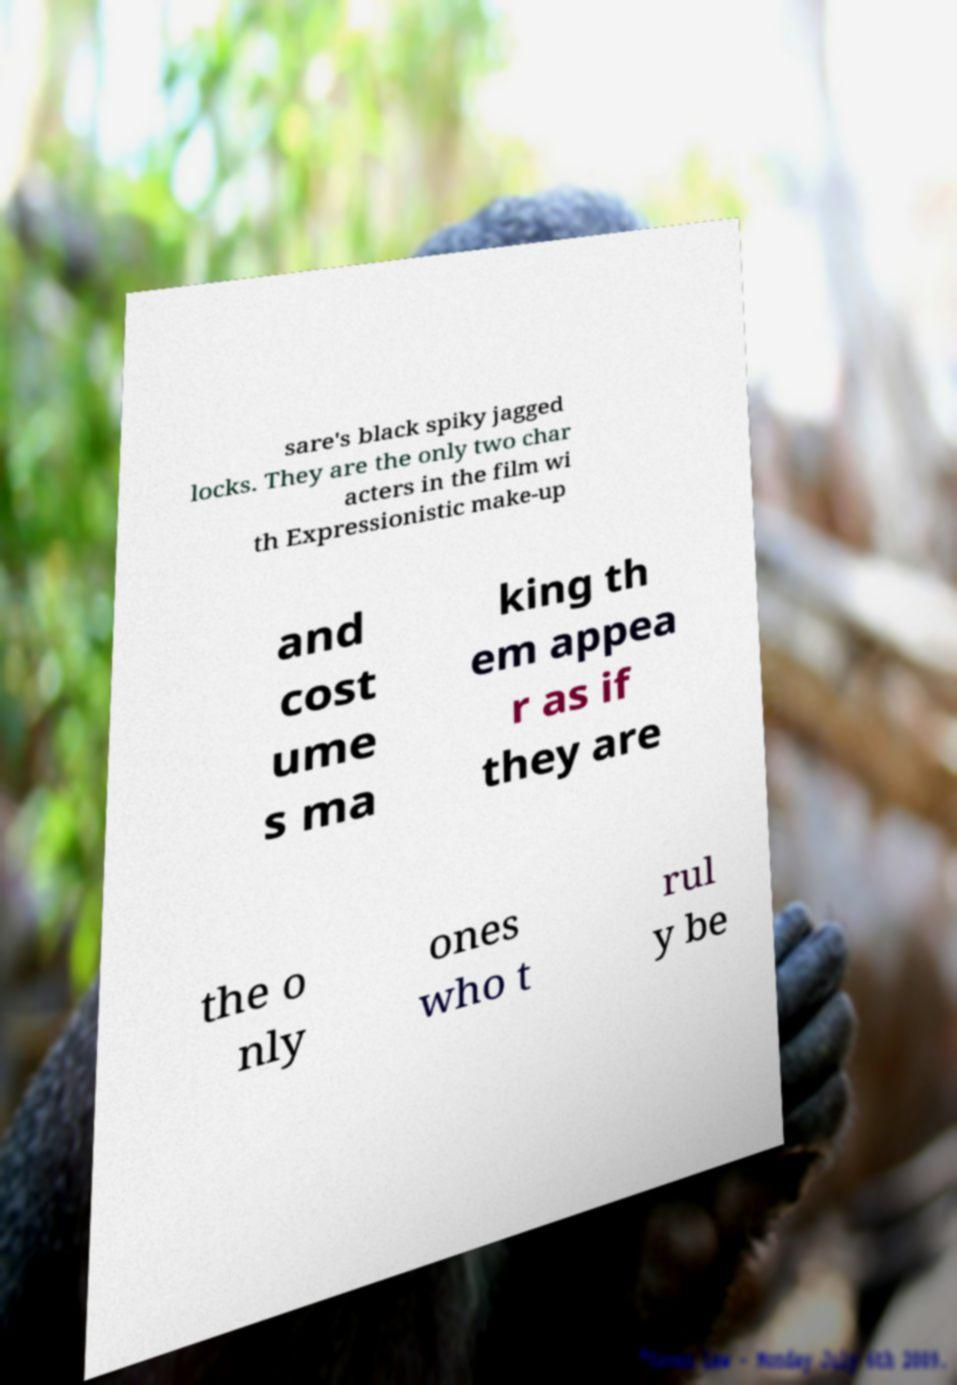Could you extract and type out the text from this image? sare's black spiky jagged locks. They are the only two char acters in the film wi th Expressionistic make-up and cost ume s ma king th em appea r as if they are the o nly ones who t rul y be 